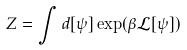Convert formula to latex. <formula><loc_0><loc_0><loc_500><loc_500>Z = \int d [ \psi ] \exp ( \beta \mathcal { L } [ \psi ] )</formula> 